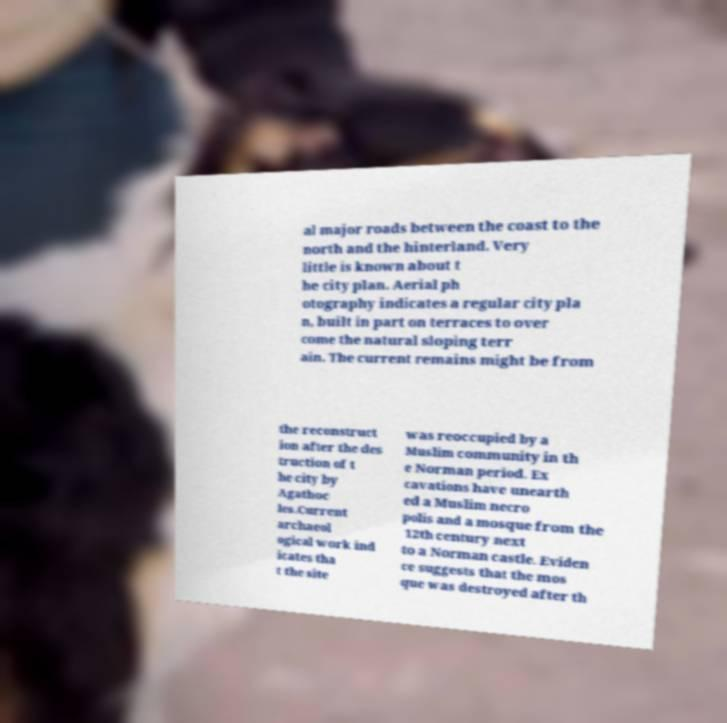There's text embedded in this image that I need extracted. Can you transcribe it verbatim? al major roads between the coast to the north and the hinterland. Very little is known about t he city plan. Aerial ph otography indicates a regular city pla n, built in part on terraces to over come the natural sloping terr ain. The current remains might be from the reconstruct ion after the des truction of t he city by Agathoc les.Current archaeol ogical work ind icates tha t the site was reoccupied by a Muslim community in th e Norman period. Ex cavations have unearth ed a Muslim necro polis and a mosque from the 12th century next to a Norman castle. Eviden ce suggests that the mos que was destroyed after th 